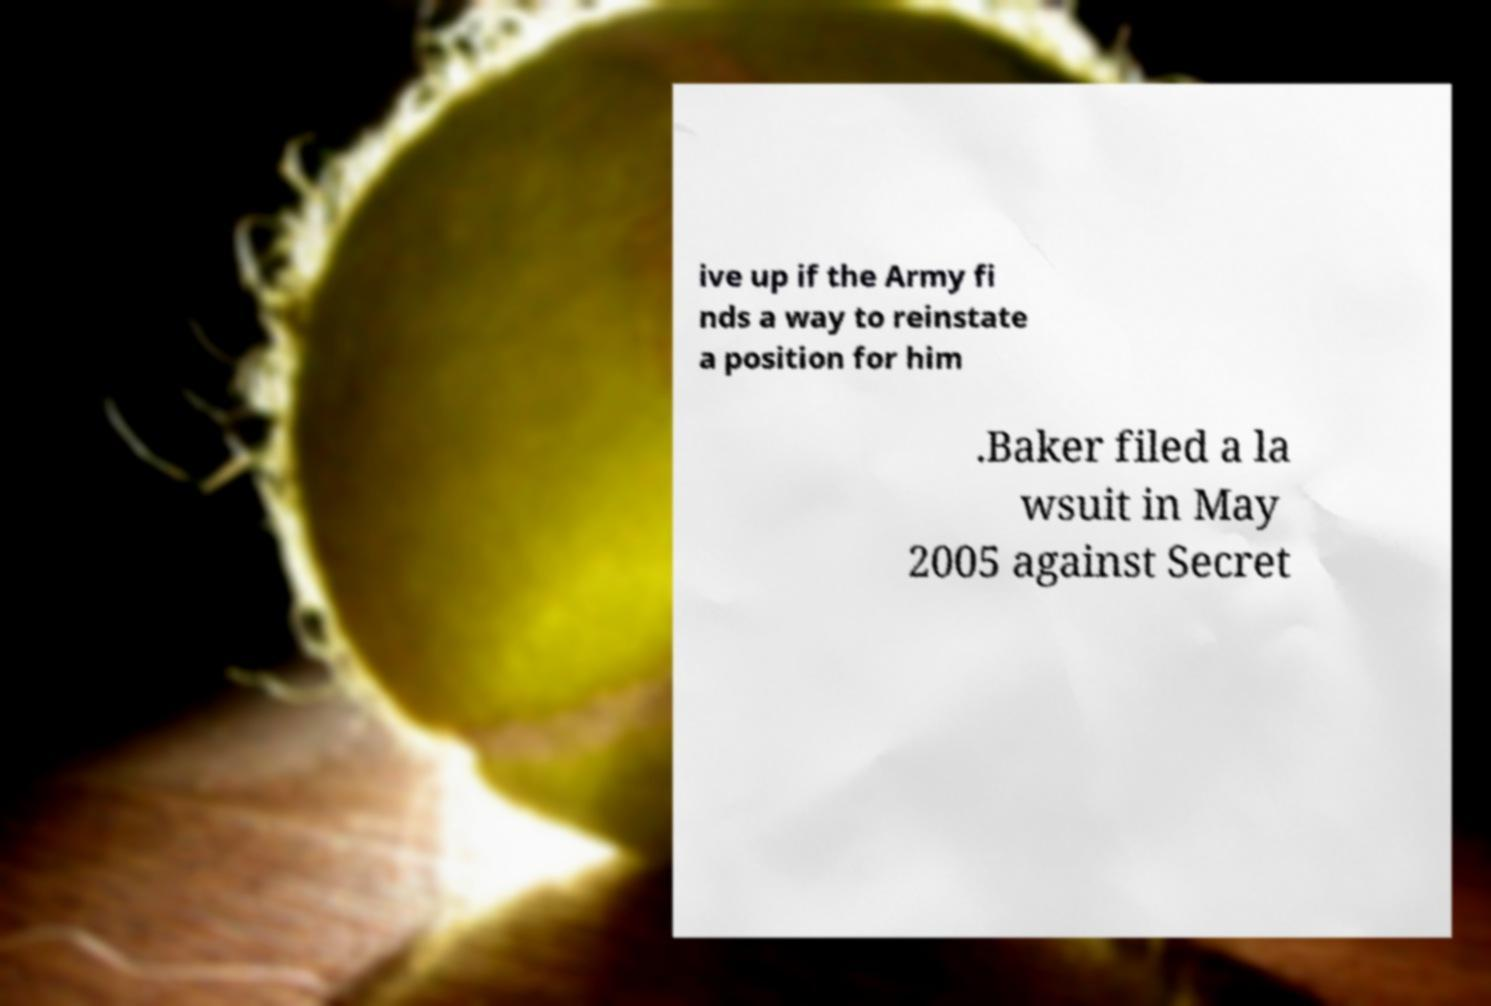Can you read and provide the text displayed in the image?This photo seems to have some interesting text. Can you extract and type it out for me? ive up if the Army fi nds a way to reinstate a position for him .Baker filed a la wsuit in May 2005 against Secret 